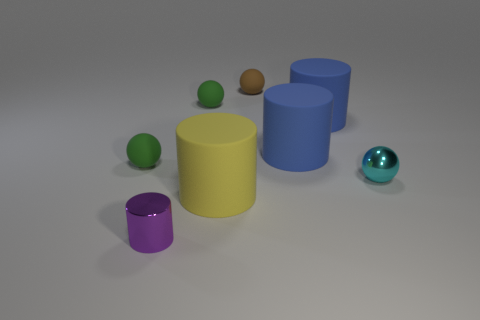Is there any other thing that is the same shape as the cyan shiny object?
Your answer should be compact. Yes. There is a tiny object that is made of the same material as the small cyan ball; what color is it?
Give a very brief answer. Purple. What number of things are either big red cubes or small green matte balls?
Your answer should be compact. 2. Do the brown sphere and the metallic object behind the purple metal thing have the same size?
Offer a terse response. Yes. The small shiny thing to the right of the yellow cylinder on the right side of the small metallic thing in front of the tiny metallic sphere is what color?
Your response must be concise. Cyan. What is the color of the metallic sphere?
Keep it short and to the point. Cyan. Are there more balls that are left of the yellow matte object than small metallic cylinders behind the brown object?
Offer a terse response. Yes. There is a tiny brown matte thing; is it the same shape as the thing that is in front of the yellow cylinder?
Your answer should be compact. No. There is a green rubber thing to the right of the tiny purple shiny cylinder; is it the same size as the green matte sphere on the left side of the tiny purple metallic cylinder?
Offer a very short reply. Yes. Is there a green sphere that is behind the green ball on the left side of the small shiny thing that is in front of the cyan sphere?
Provide a succinct answer. Yes. 